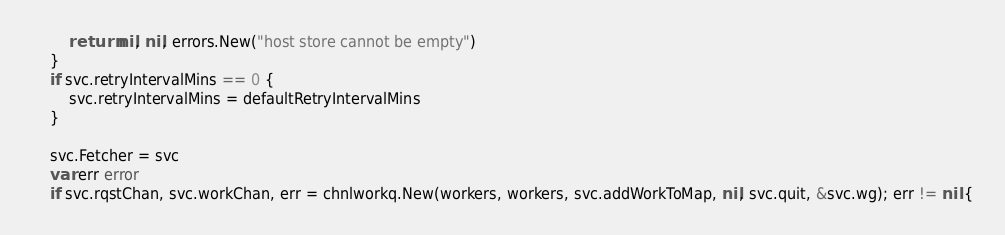<code> <loc_0><loc_0><loc_500><loc_500><_Go_>		return nil, nil, errors.New("host store cannot be empty")
	}
	if svc.retryIntervalMins == 0 {
		svc.retryIntervalMins = defaultRetryIntervalMins
	}

	svc.Fetcher = svc
	var err error
	if svc.rqstChan, svc.workChan, err = chnlworkq.New(workers, workers, svc.addWorkToMap, nil, svc.quit, &svc.wg); err != nil {</code> 